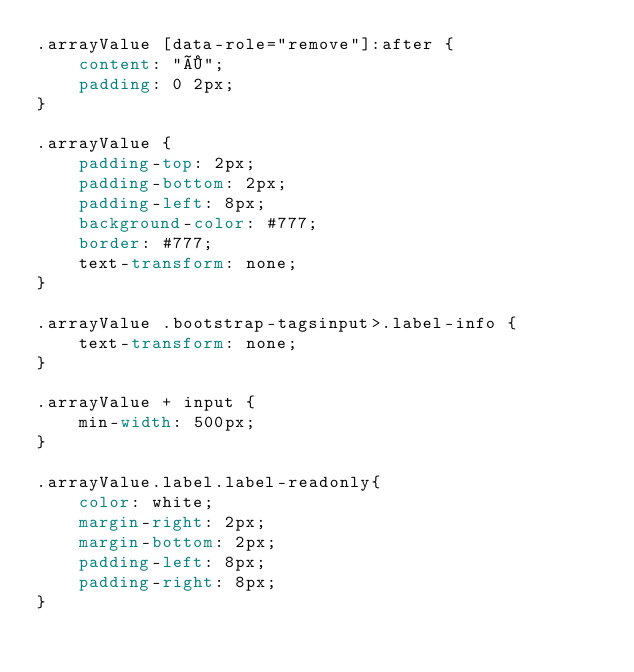Convert code to text. <code><loc_0><loc_0><loc_500><loc_500><_CSS_>.arrayValue [data-role="remove"]:after {
    content: "×";
    padding: 0 2px;
}

.arrayValue {
    padding-top: 2px;
    padding-bottom: 2px;
    padding-left: 8px;
    background-color: #777;
    border: #777;
    text-transform: none;
}

.arrayValue .bootstrap-tagsinput>.label-info {
    text-transform: none;
}

.arrayValue + input {
    min-width: 500px;
}

.arrayValue.label.label-readonly{
    color: white;
    margin-right: 2px;
    margin-bottom: 2px;
    padding-left: 8px;
    padding-right: 8px;
}</code> 